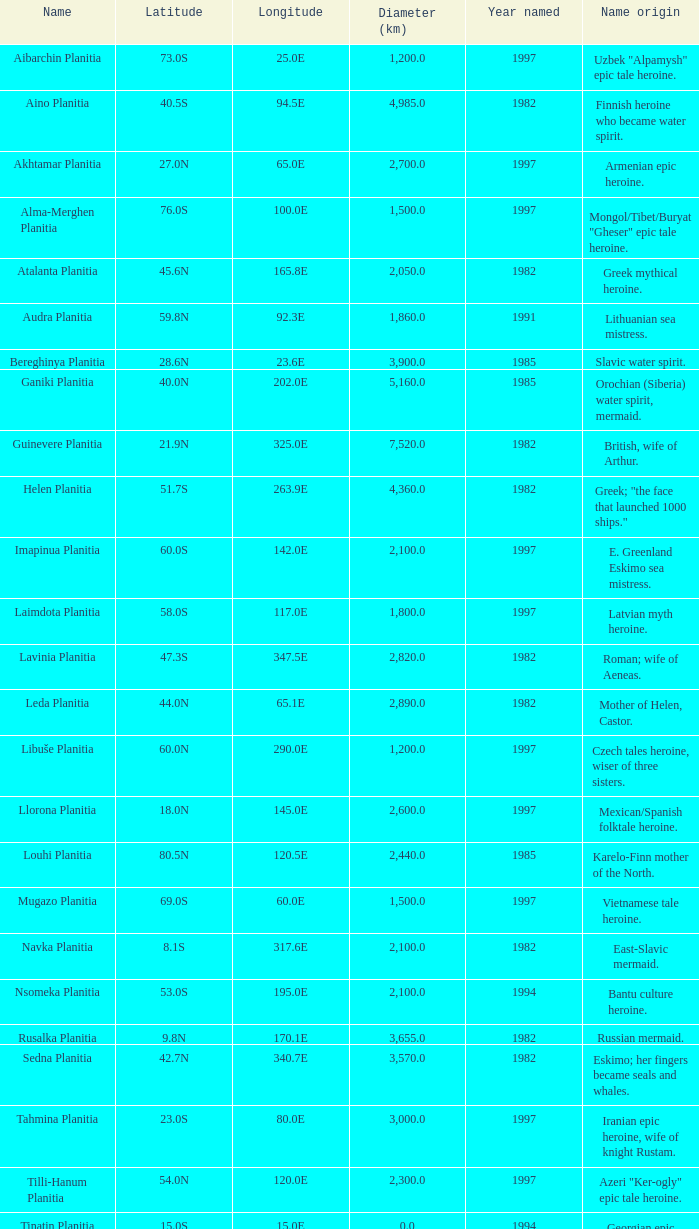What is the diameter (km) of the feature of latitude 23.0s 3000.0. 